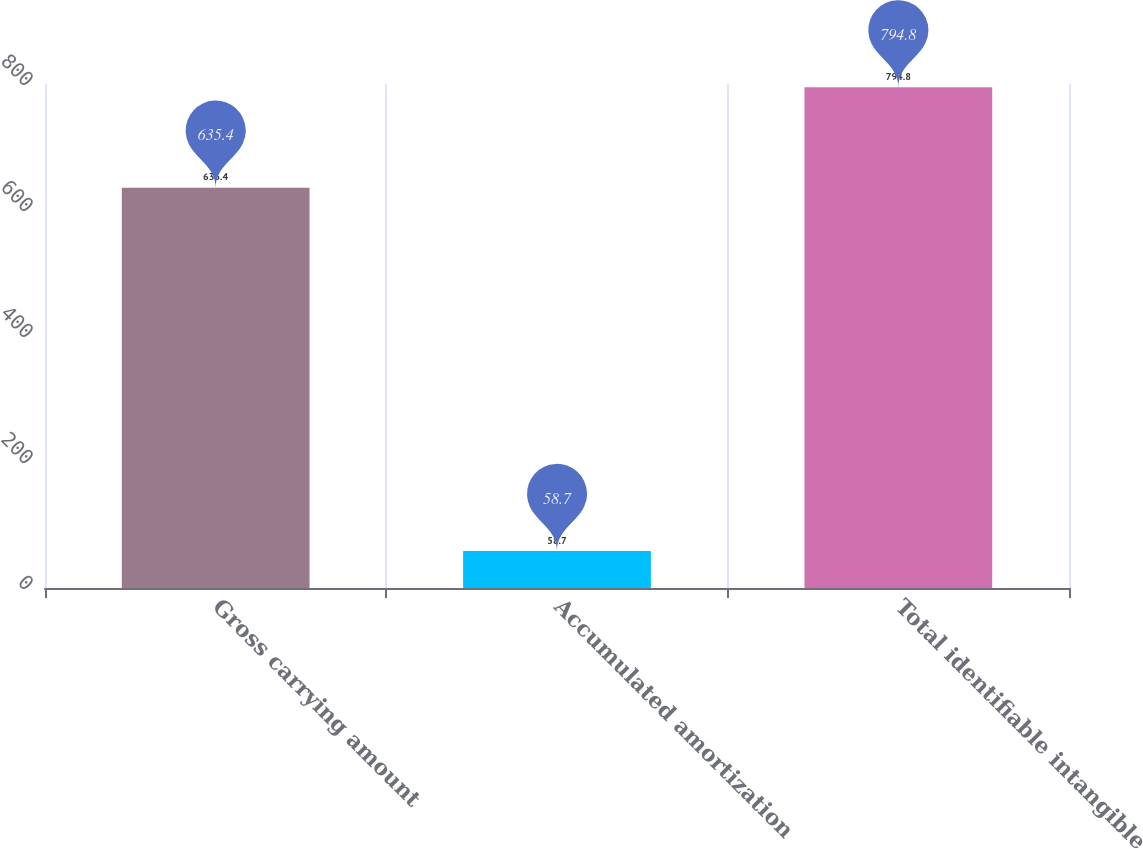Convert chart. <chart><loc_0><loc_0><loc_500><loc_500><bar_chart><fcel>Gross carrying amount<fcel>Accumulated amortization<fcel>Total identifiable intangible<nl><fcel>635.4<fcel>58.7<fcel>794.8<nl></chart> 